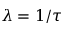<formula> <loc_0><loc_0><loc_500><loc_500>\lambda = 1 / \tau</formula> 